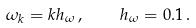<formula> <loc_0><loc_0><loc_500><loc_500>\omega _ { k } = k h _ { \omega } \, , \quad h _ { \omega } = 0 . 1 \, .</formula> 